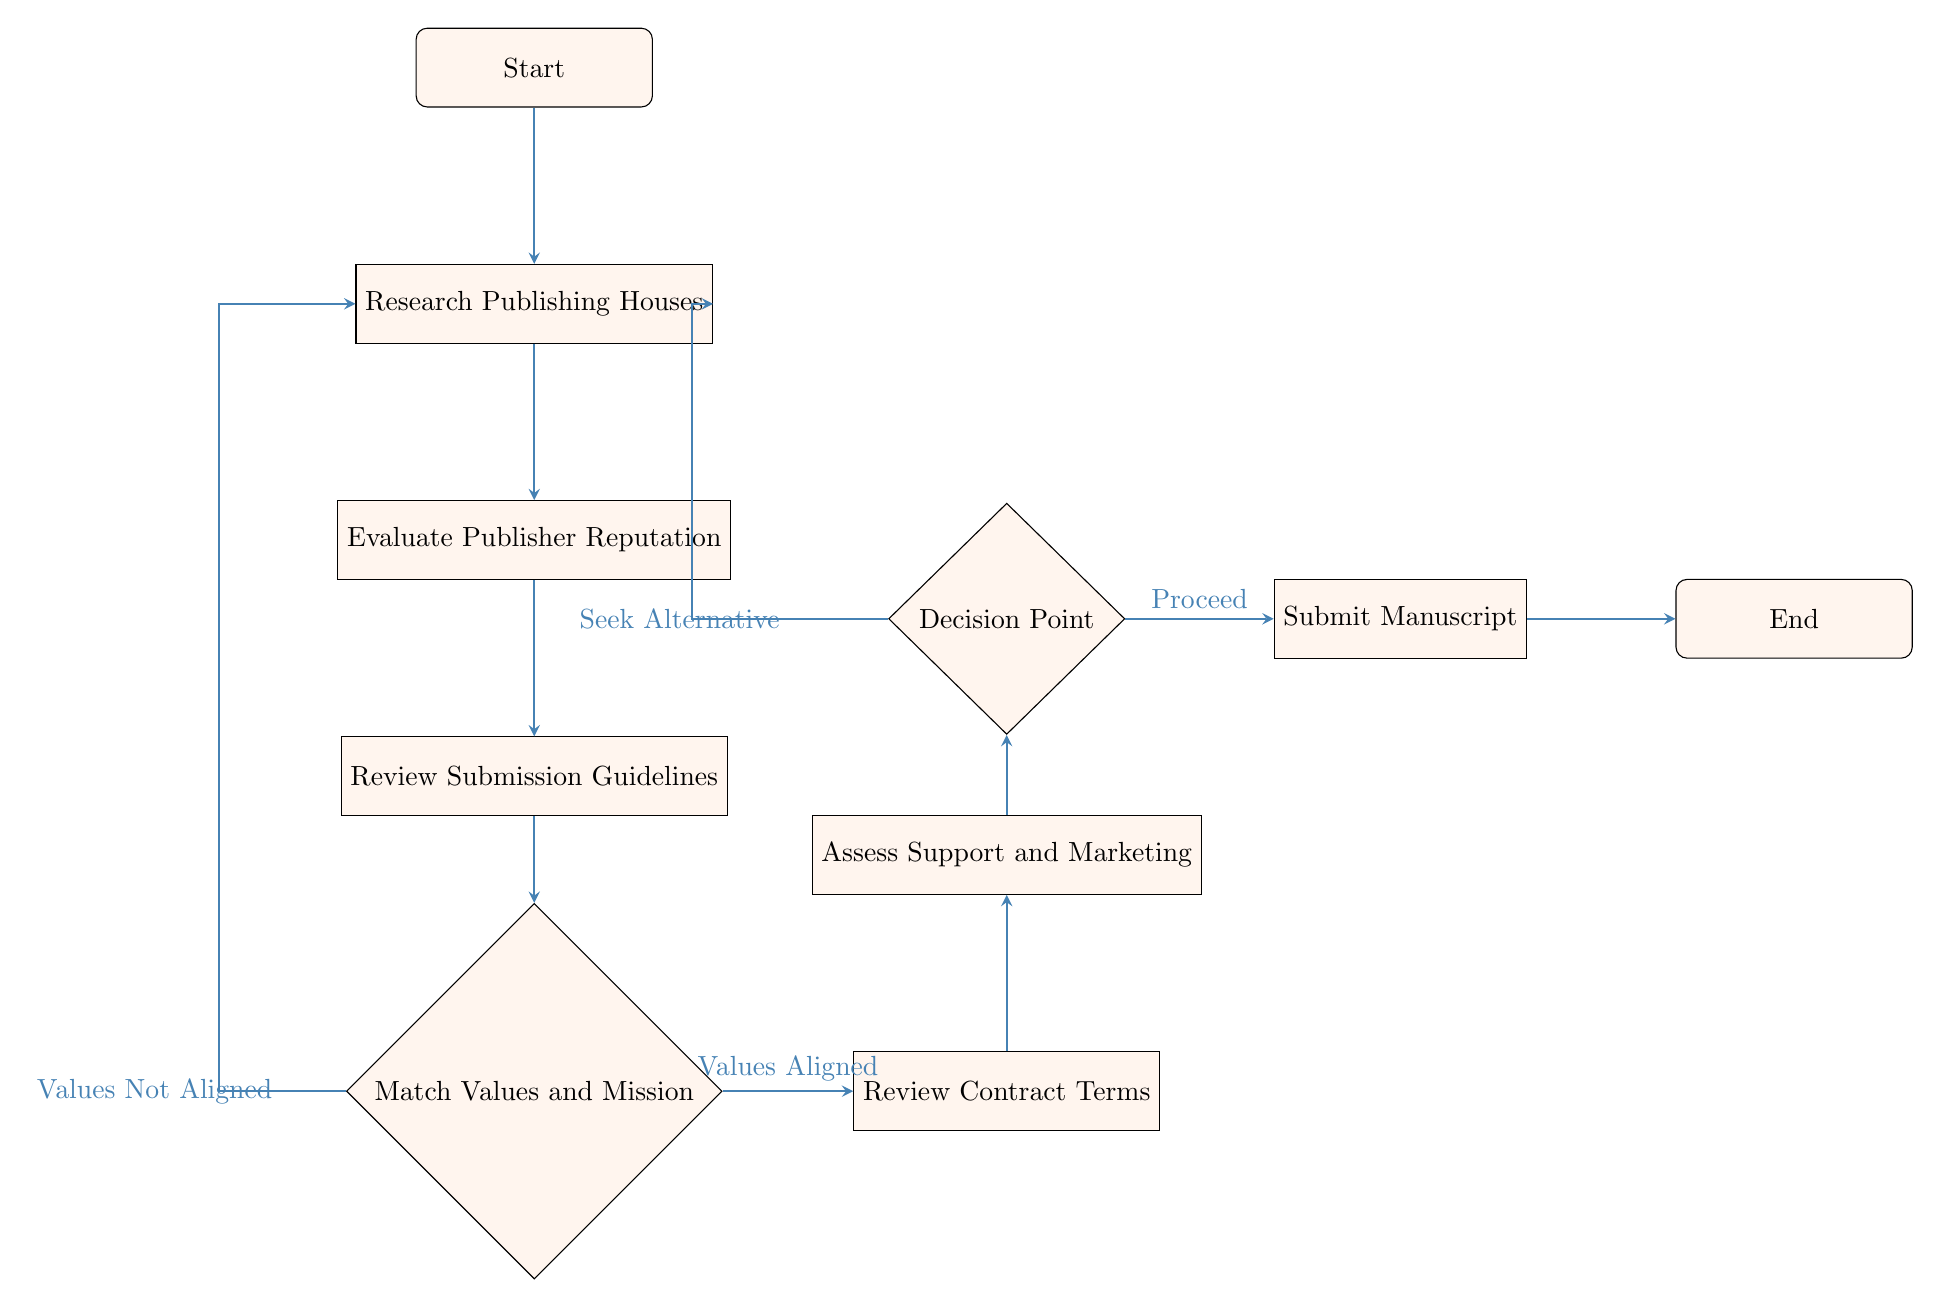What is the first step in the decision-making process? The first step is indicated by the "Start" node, which signifies the beginning of the process of selecting a publishing house.
Answer: Start How many decision points are present in the diagram? There are two decision points in the flow chart: "Match Values and Mission" and "Decision Point."
Answer: 2 What follows after reviewing submission guidelines? Directly below "Review Submission Guidelines," the next step is "Match Values and Mission."
Answer: Match Values and Mission If the publisher's values are not aligned, what is the outcome? According to the diagram, if the values are not aligned, the process loops back to "Research Publishing Houses" to seek alternatives.
Answer: Research Publishing Houses What does the final step entail before concluding the process? The final step before ending is "Submit Manuscript," which occurs after evaluating all previous criteria.
Answer: Submit Manuscript Is the assessment of support and marketing done before or after reviewing contract terms? "Assess Support and Marketing" occurs after "Review Contract Terms," as the arrows in the diagram indicate the flow of steps.
Answer: After What happens if the contract terms are found unacceptable? If the terms are unacceptable, the process does not proceed to submission; instead, it leads back to a decision point, which involves seeking another publisher.
Answer: Seek Alternative Publisher Which node emphasizes matching values and mission? The node specifically focusing on this aspect is titled "Match Values and Mission," shown as a decision point in the flow.
Answer: Match Values and Mission What progresses the flow if the publisher offers strong support? If "Assess Support and Marketing" concludes that there is "Strong Support," the flow moves forward to the "Decision Point."
Answer: Decision Point 